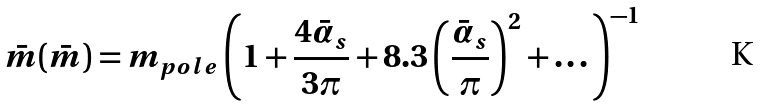Convert formula to latex. <formula><loc_0><loc_0><loc_500><loc_500>\bar { m } ( \bar { m } ) = m _ { p o l e } \left ( 1 + \frac { 4 \bar { \alpha } _ { s } } { 3 \pi } + 8 . 3 \left ( \frac { \bar { \alpha } _ { s } } { \pi } \right ) ^ { 2 } + \dots \right ) ^ { - 1 }</formula> 